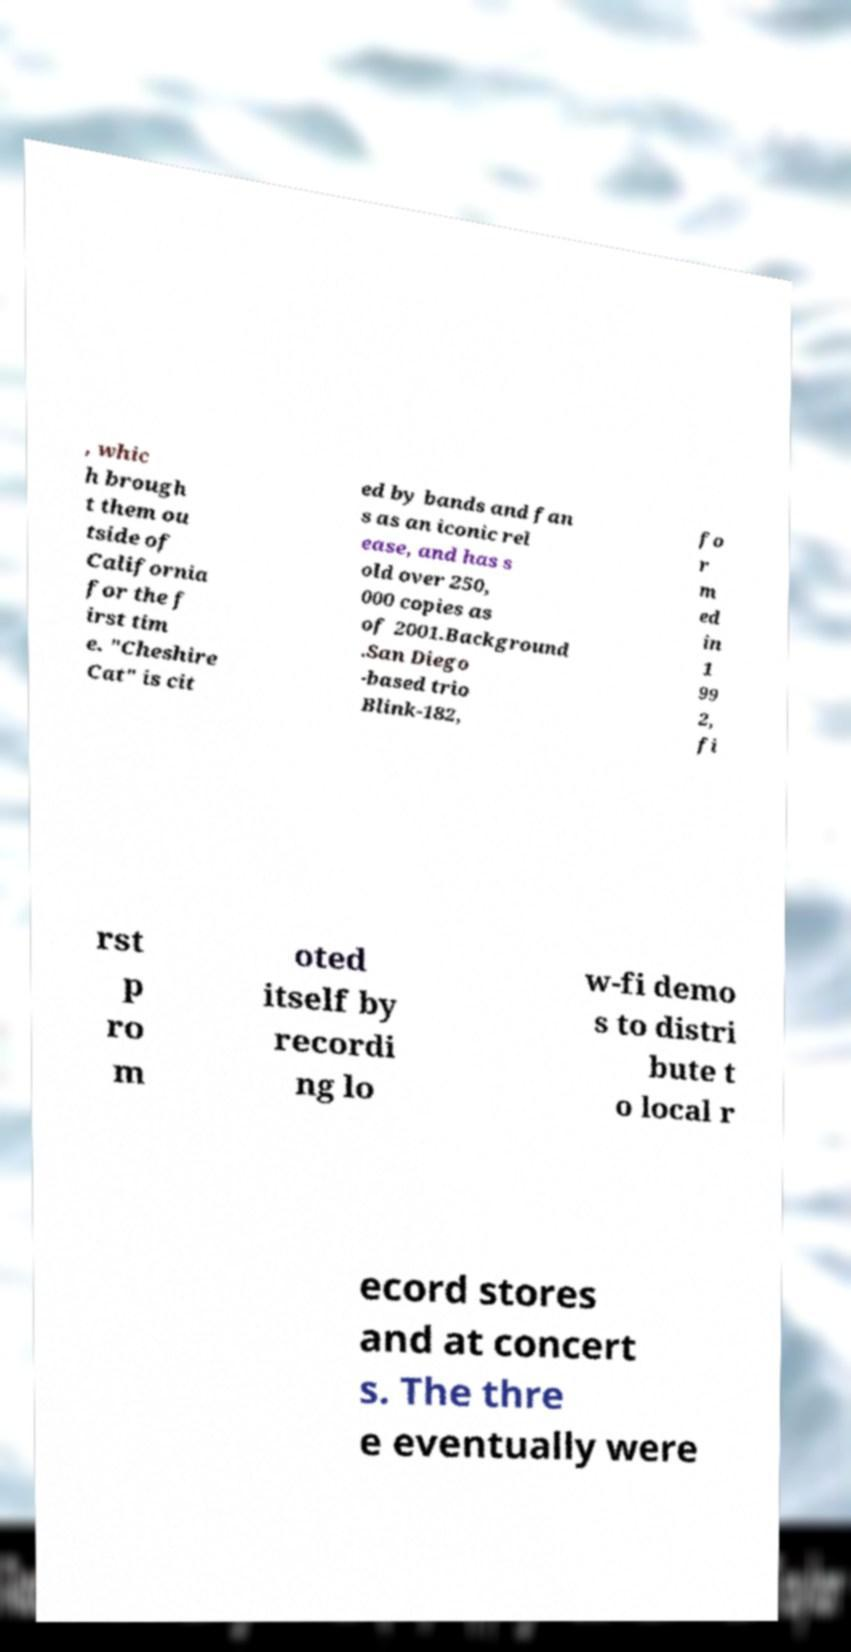Could you extract and type out the text from this image? , whic h brough t them ou tside of California for the f irst tim e. "Cheshire Cat" is cit ed by bands and fan s as an iconic rel ease, and has s old over 250, 000 copies as of 2001.Background .San Diego -based trio Blink-182, fo r m ed in 1 99 2, fi rst p ro m oted itself by recordi ng lo w-fi demo s to distri bute t o local r ecord stores and at concert s. The thre e eventually were 